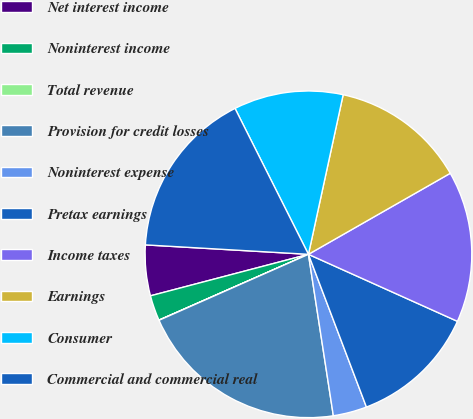Convert chart to OTSL. <chart><loc_0><loc_0><loc_500><loc_500><pie_chart><fcel>Net interest income<fcel>Noninterest income<fcel>Total revenue<fcel>Provision for credit losses<fcel>Noninterest expense<fcel>Pretax earnings<fcel>Income taxes<fcel>Earnings<fcel>Consumer<fcel>Commercial and commercial real<nl><fcel>5.01%<fcel>2.51%<fcel>0.02%<fcel>20.82%<fcel>3.34%<fcel>12.5%<fcel>14.99%<fcel>13.33%<fcel>10.83%<fcel>16.66%<nl></chart> 